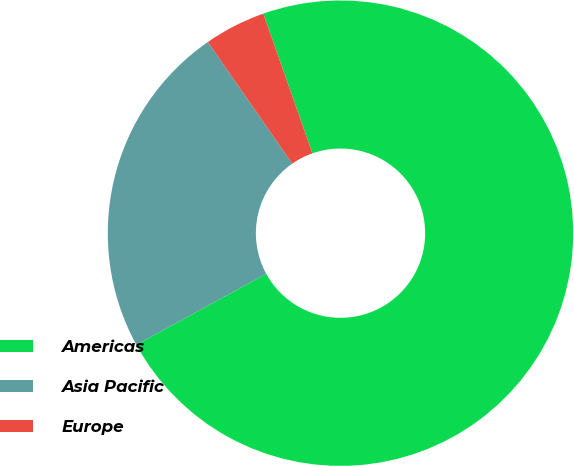Convert chart. <chart><loc_0><loc_0><loc_500><loc_500><pie_chart><fcel>Americas<fcel>Asia Pacific<fcel>Europe<nl><fcel>72.41%<fcel>23.31%<fcel>4.27%<nl></chart> 